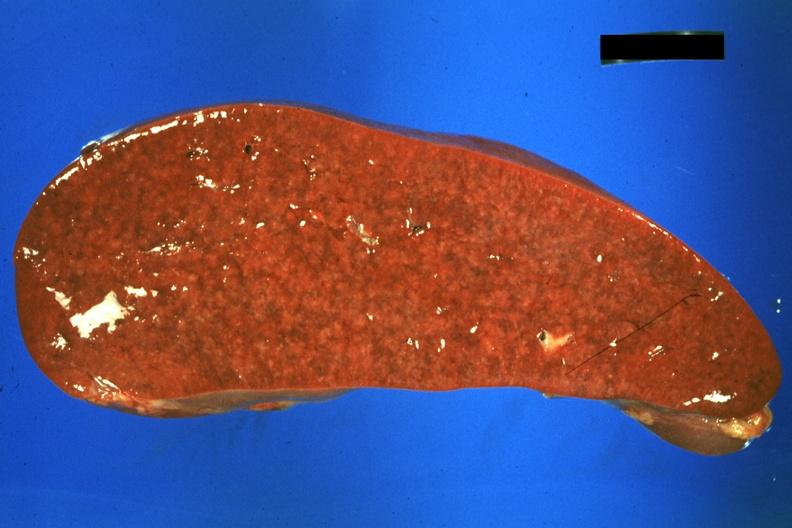s sarcoidosis present?
Answer the question using a single word or phrase. Yes 